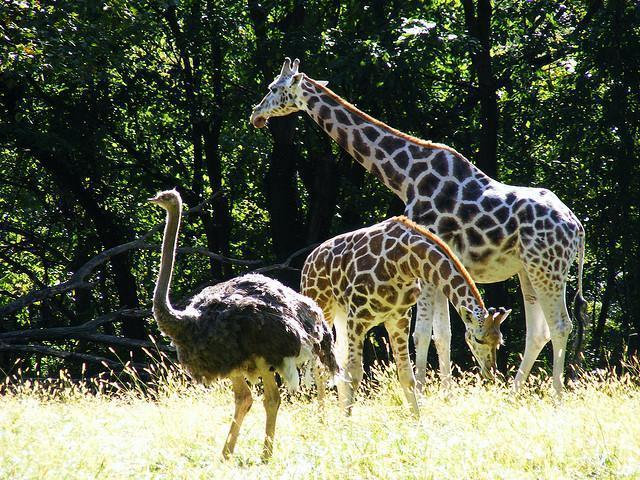How many giraffes are there?
Give a very brief answer. 2. How many people are holding book in their hand ?
Give a very brief answer. 0. 